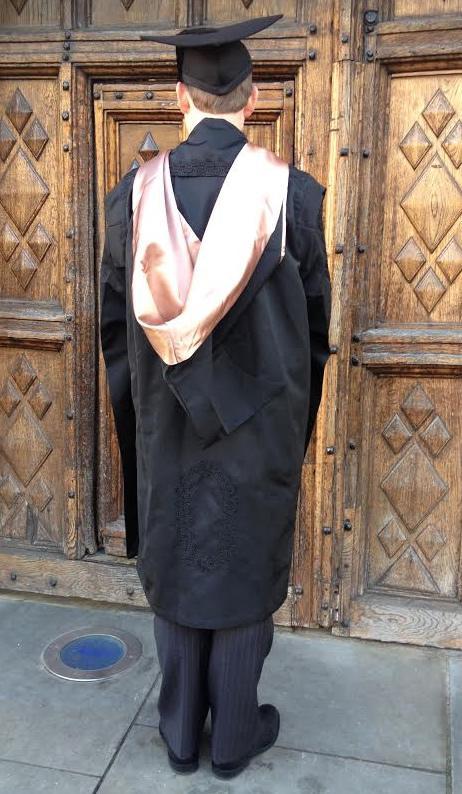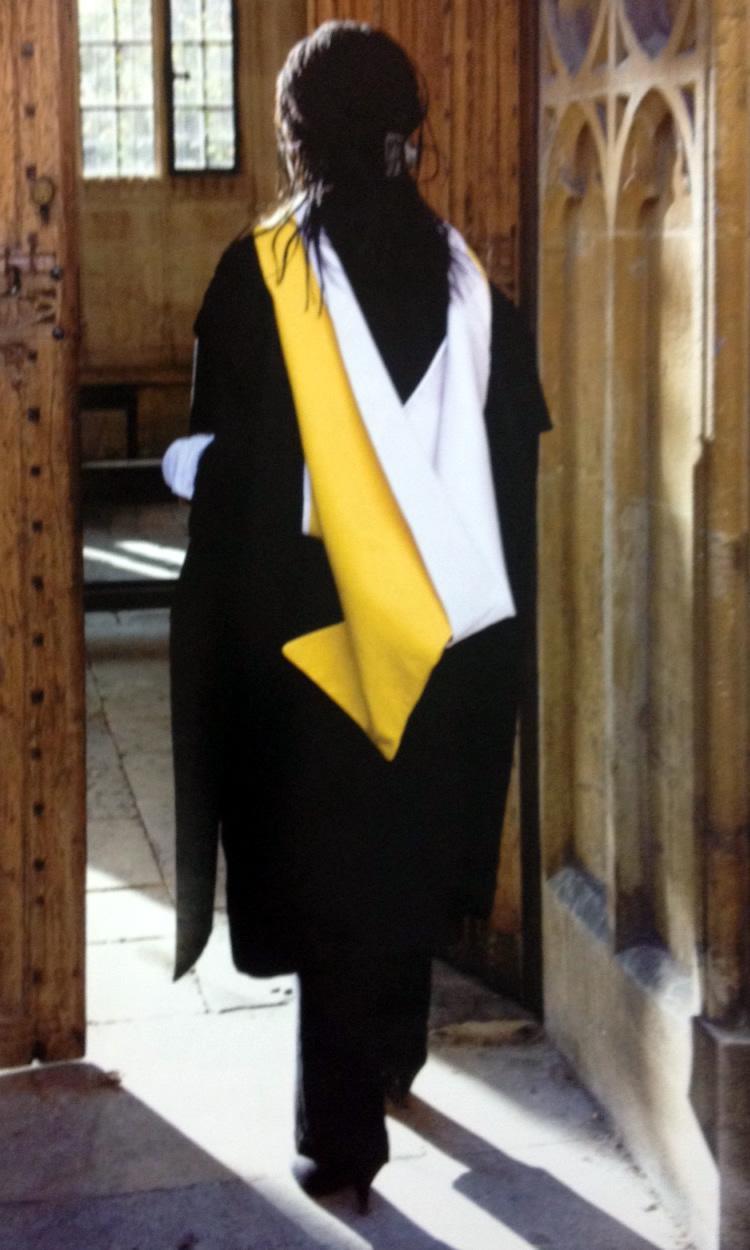The first image is the image on the left, the second image is the image on the right. Given the left and right images, does the statement "An image shows only one person modeling graduation attire, a long-haired female who is not facing the camera." hold true? Answer yes or no. Yes. The first image is the image on the left, the second image is the image on the right. For the images displayed, is the sentence "An image contains more than one graduation student." factually correct? Answer yes or no. No. 